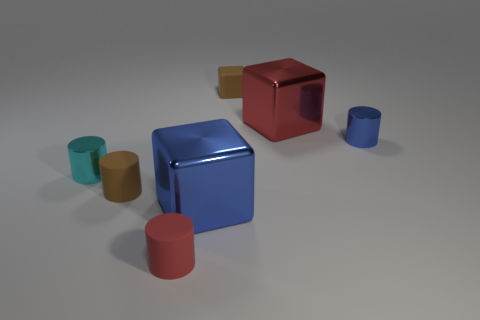Subtract all blue cylinders. How many cylinders are left? 3 Subtract all gray cylinders. Subtract all brown balls. How many cylinders are left? 4 Add 2 green matte cubes. How many objects exist? 9 Subtract all cylinders. How many objects are left? 3 Subtract all tiny rubber blocks. Subtract all small brown matte cylinders. How many objects are left? 5 Add 1 red metal blocks. How many red metal blocks are left? 2 Add 5 cubes. How many cubes exist? 8 Subtract 0 cyan blocks. How many objects are left? 7 